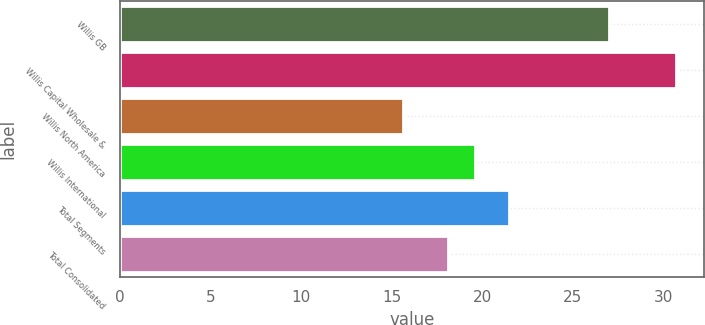<chart> <loc_0><loc_0><loc_500><loc_500><bar_chart><fcel>Willis GB<fcel>Willis Capital Wholesale &<fcel>Willis North America<fcel>Willis International<fcel>Total Segments<fcel>Total Consolidated<nl><fcel>27<fcel>30.7<fcel>15.6<fcel>19.61<fcel>21.5<fcel>18.1<nl></chart> 